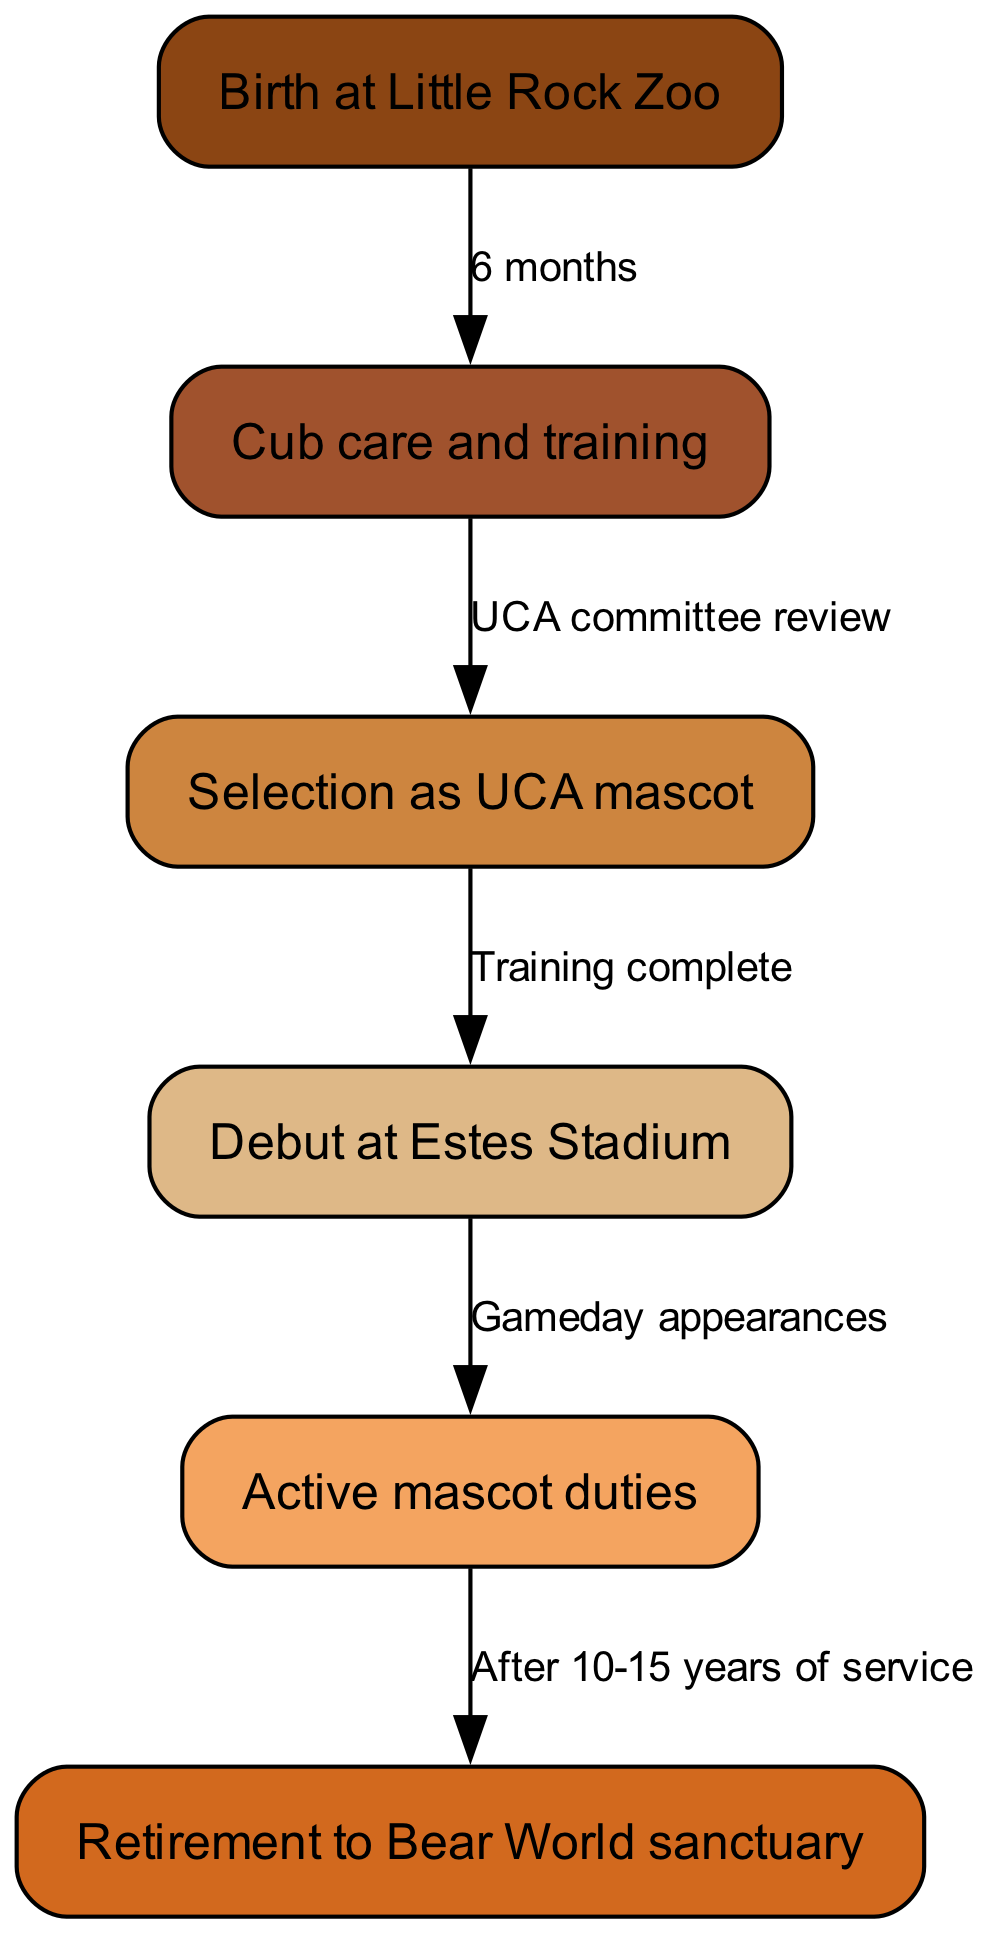What is the first step in the UCA bear mascot's life cycle? The first step, or node in the life cycle diagram, is "Birth at Little Rock Zoo." This is indicated as the starting point of the life cycle sequence.
Answer: Birth at Little Rock Zoo How long does the cub care and training stage last? According to the edge label connecting the first node to the second, the cub care and training stage lasts "6 months." This indicates the duration from birth to the next stage.
Answer: 6 months What is the second step after cub care and training? The second step, following cub care and training, is "Selection as UCA mascot." This is found directly after the training stage in the sequence of nodes.
Answer: Selection as UCA mascot What occurs after the UCA mascot makes its debut? After the debut at "Estes Stadium," the next step is "Active mascot duties." This follows from the edge that connects the fourth node to the fifth, demonstrating the progression from debut to active service.
Answer: Active mascot duties How many years of service must a mascot typically complete before retirement? The diagram specifies that the typical years of active service before retirement is "10-15 years," which is indicated on the edge leading from active mascot duties to retirement.
Answer: 10-15 years What is the final stage of the UCA bear mascot's life cycle? The final stage is "Retirement to Bear World sanctuary." This is the last node in the diagram that signifies the completion of the mascot's life cycle.
Answer: Retirement to Bear World sanctuary What is the connection between "Selection as UCA mascot" and "Debut at Estes Stadium"? The connection is labeled "Training complete," indicating that once the mascot is selected, it undergoes training before debuting at the stadium. This can be traced along the directed edge from the third node to the fourth.
Answer: Training complete Which node has the most direct connection to "Active mascot duties"? The most direct connection to "Active mascot duties" is from "Debut at Estes Stadium," as it is the immediate predecessor in the life cycle flow. The diagram shows a clear edge moving from the fourth step to the fifth.
Answer: Debut at Estes Stadium How many nodes are in the UCA bear mascot life cycle diagram? There are a total of six nodes present in the diagram, each representing a key stage in the mascot's life cycle. This can be counted directly from the given data about the nodes.
Answer: 6 